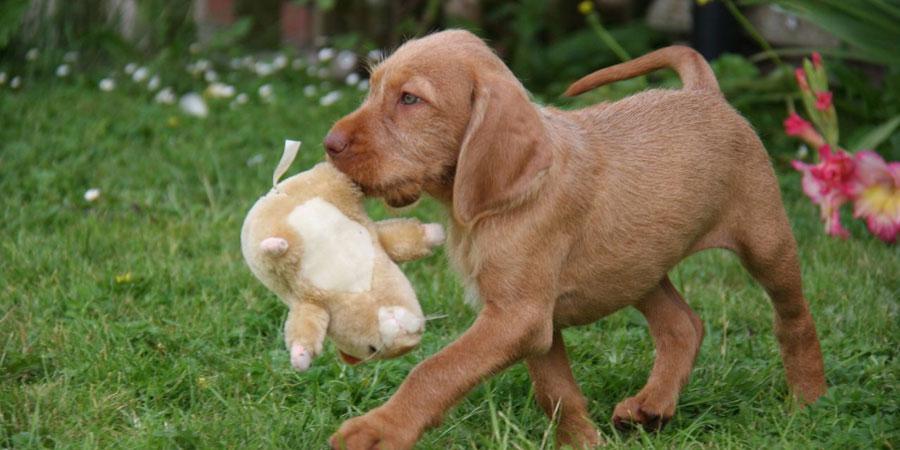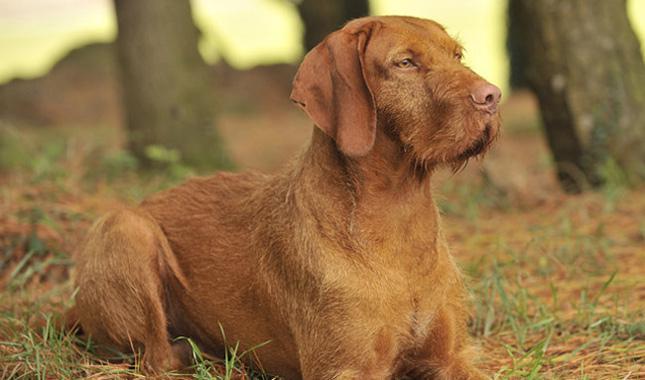The first image is the image on the left, the second image is the image on the right. Evaluate the accuracy of this statement regarding the images: "In one image, a dog is carrying a stuffed animal in its mouth.". Is it true? Answer yes or no. Yes. 